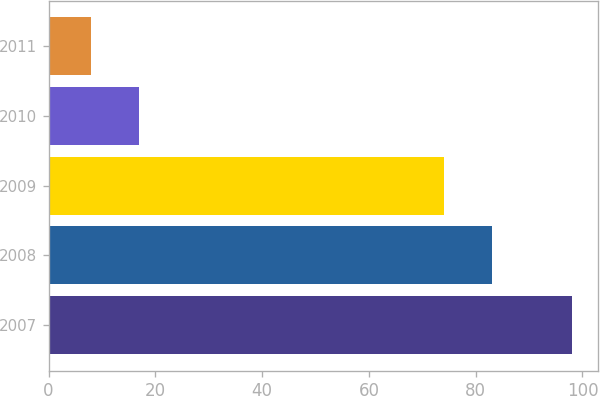Convert chart. <chart><loc_0><loc_0><loc_500><loc_500><bar_chart><fcel>2007<fcel>2008<fcel>2009<fcel>2010<fcel>2011<nl><fcel>98<fcel>83<fcel>74<fcel>17<fcel>8<nl></chart> 